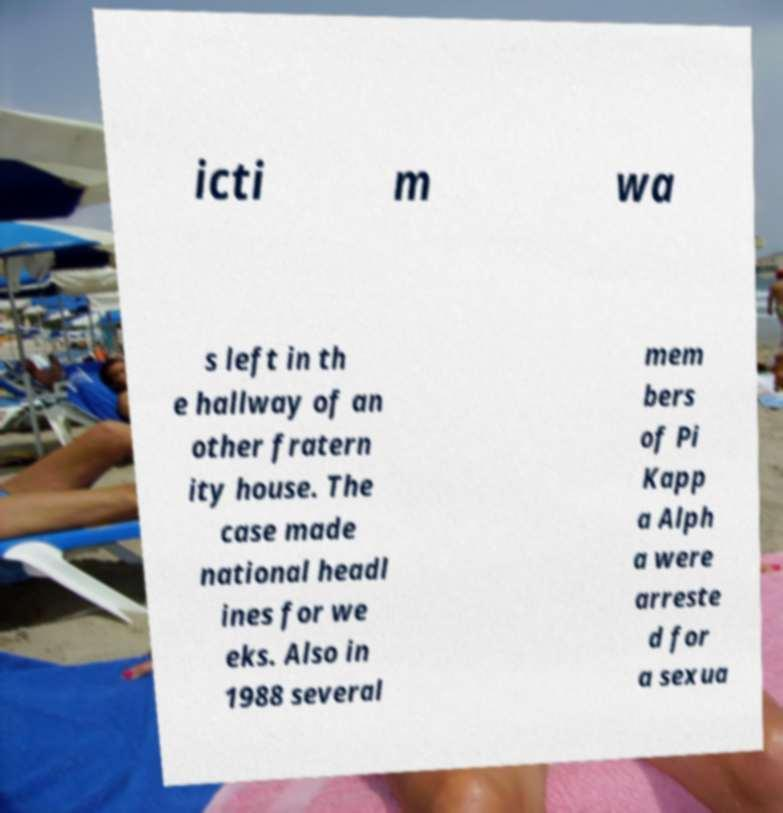There's text embedded in this image that I need extracted. Can you transcribe it verbatim? icti m wa s left in th e hallway of an other fratern ity house. The case made national headl ines for we eks. Also in 1988 several mem bers of Pi Kapp a Alph a were arreste d for a sexua 